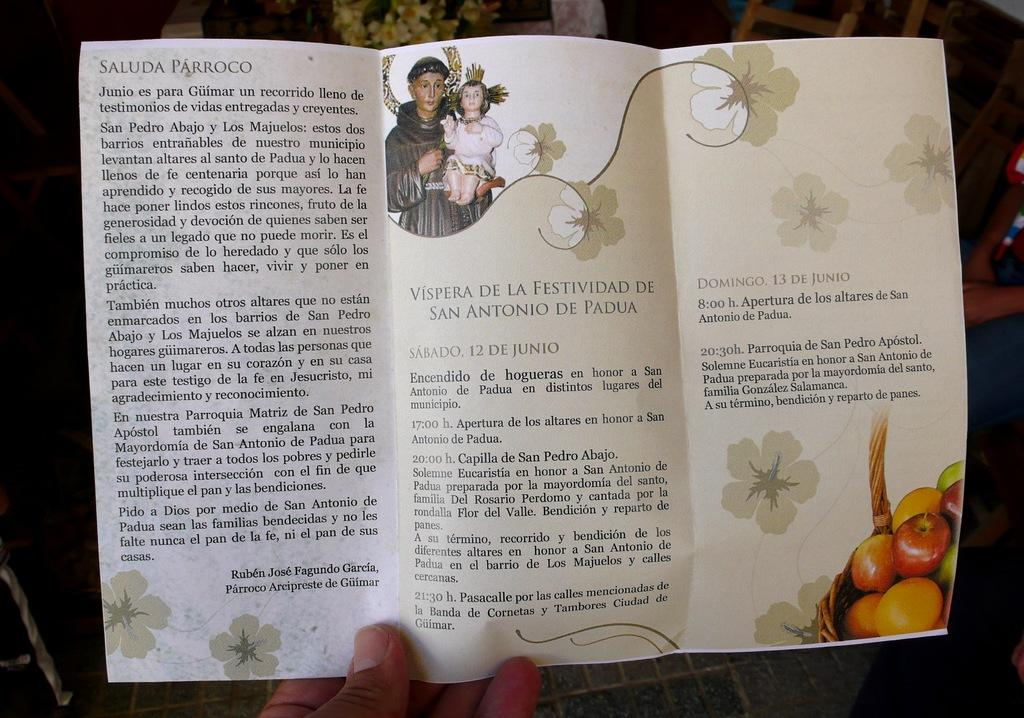What is the person in the image holding? The person is holding a brochure in the image. What can be seen on the brochure? The brochure has two pictures on it and writing. What else can be seen in the background of the image? There are other objects in the background of the image. What shape is the pot in the image? There is no pot present in the image. 